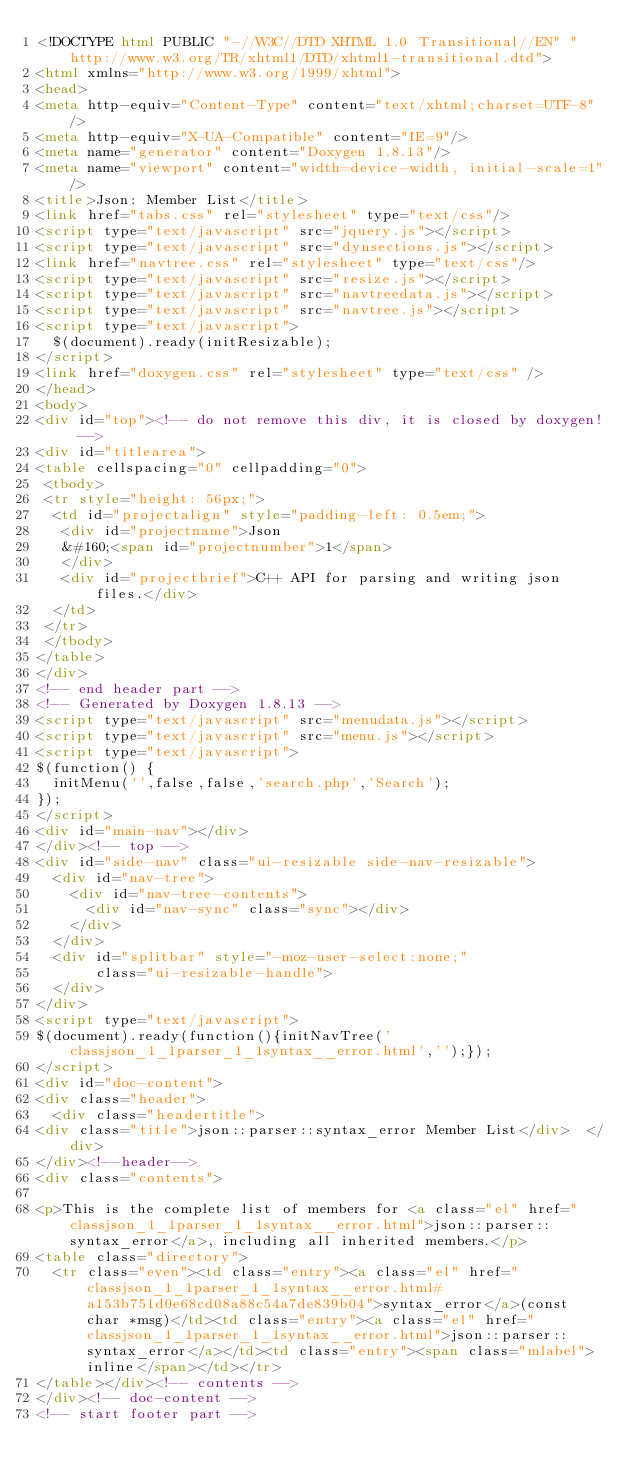<code> <loc_0><loc_0><loc_500><loc_500><_HTML_><!DOCTYPE html PUBLIC "-//W3C//DTD XHTML 1.0 Transitional//EN" "http://www.w3.org/TR/xhtml1/DTD/xhtml1-transitional.dtd">
<html xmlns="http://www.w3.org/1999/xhtml">
<head>
<meta http-equiv="Content-Type" content="text/xhtml;charset=UTF-8"/>
<meta http-equiv="X-UA-Compatible" content="IE=9"/>
<meta name="generator" content="Doxygen 1.8.13"/>
<meta name="viewport" content="width=device-width, initial-scale=1"/>
<title>Json: Member List</title>
<link href="tabs.css" rel="stylesheet" type="text/css"/>
<script type="text/javascript" src="jquery.js"></script>
<script type="text/javascript" src="dynsections.js"></script>
<link href="navtree.css" rel="stylesheet" type="text/css"/>
<script type="text/javascript" src="resize.js"></script>
<script type="text/javascript" src="navtreedata.js"></script>
<script type="text/javascript" src="navtree.js"></script>
<script type="text/javascript">
  $(document).ready(initResizable);
</script>
<link href="doxygen.css" rel="stylesheet" type="text/css" />
</head>
<body>
<div id="top"><!-- do not remove this div, it is closed by doxygen! -->
<div id="titlearea">
<table cellspacing="0" cellpadding="0">
 <tbody>
 <tr style="height: 56px;">
  <td id="projectalign" style="padding-left: 0.5em;">
   <div id="projectname">Json
   &#160;<span id="projectnumber">1</span>
   </div>
   <div id="projectbrief">C++ API for parsing and writing json files.</div>
  </td>
 </tr>
 </tbody>
</table>
</div>
<!-- end header part -->
<!-- Generated by Doxygen 1.8.13 -->
<script type="text/javascript" src="menudata.js"></script>
<script type="text/javascript" src="menu.js"></script>
<script type="text/javascript">
$(function() {
  initMenu('',false,false,'search.php','Search');
});
</script>
<div id="main-nav"></div>
</div><!-- top -->
<div id="side-nav" class="ui-resizable side-nav-resizable">
  <div id="nav-tree">
    <div id="nav-tree-contents">
      <div id="nav-sync" class="sync"></div>
    </div>
  </div>
  <div id="splitbar" style="-moz-user-select:none;" 
       class="ui-resizable-handle">
  </div>
</div>
<script type="text/javascript">
$(document).ready(function(){initNavTree('classjson_1_1parser_1_1syntax__error.html','');});
</script>
<div id="doc-content">
<div class="header">
  <div class="headertitle">
<div class="title">json::parser::syntax_error Member List</div>  </div>
</div><!--header-->
<div class="contents">

<p>This is the complete list of members for <a class="el" href="classjson_1_1parser_1_1syntax__error.html">json::parser::syntax_error</a>, including all inherited members.</p>
<table class="directory">
  <tr class="even"><td class="entry"><a class="el" href="classjson_1_1parser_1_1syntax__error.html#a153b751d0e68cd08a88c54a7de839b04">syntax_error</a>(const char *msg)</td><td class="entry"><a class="el" href="classjson_1_1parser_1_1syntax__error.html">json::parser::syntax_error</a></td><td class="entry"><span class="mlabel">inline</span></td></tr>
</table></div><!-- contents -->
</div><!-- doc-content -->
<!-- start footer part --></code> 